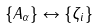Convert formula to latex. <formula><loc_0><loc_0><loc_500><loc_500>\{ A _ { \alpha } \} \leftrightarrow \{ \zeta _ { i } \}</formula> 